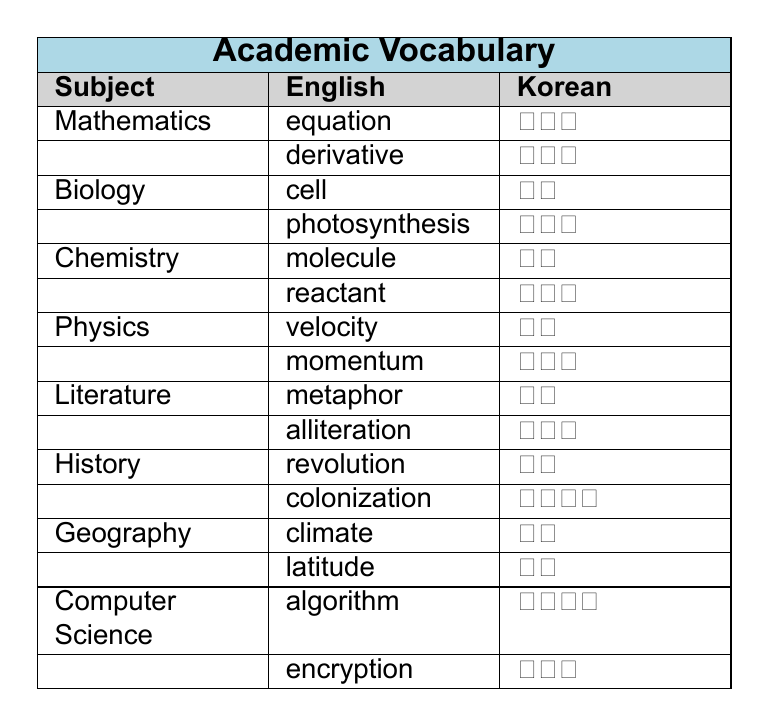What is the Korean word for 'algorithm'? From the vocabulary list, under the subject 'Computer Science', the English word 'algorithm' corresponds to the Korean word '알고리즘'.
Answer: 알고리즘 Which subject has the term 'momentum'? Referring to the table, 'momentum' is listed under the subject 'Physics'.
Answer: Physics How many vocabulary terms are listed for the subject 'Biology'? The vocabulary for 'Biology' includes two terms: 'cell' and 'photosynthesis'. Therefore, the count is 2.
Answer: 2 What English word corresponds to '혁명'? Looking at the table, '혁명' is the Korean word that translates to 'revolution' in English, found under the subject 'History'.
Answer: revolution Is 'molecule' included in the vocabulary list for Mathematics? Checking the table, 'molecule' is not under Mathematics; it is listed under Chemistry. Therefore, the answer is no.
Answer: No Which subject has the term 'latitude'? In the table, 'latitude' is identified under the subject 'Geography'.
Answer: Geography What are the English words for the subjects of 'Chemistry' and 'Literature'? 'Chemistry' has 'molecule' and 'reactant'; 'Literature' has 'metaphor' and 'alliteration'. Thus, the total words are four: molecule, reactant, metaphor, alliteration.
Answer: molecule, reactant, metaphor, alliteration Count the total number of vocabulary terms in the table. There are 16 vocabulary terms total, as each subject has 2 terms listed. Summing them gives 8 subjects x 2 terms each = 16.
Answer: 16 Does the subject 'Geography' include the word 'climate'? The table displays 'climate' under the subject 'Geography', confirming its inclusion. Therefore, the answer is yes.
Answer: Yes Which academic subject has the most vocabulary entries? All subjects have the same number of entries (2 each), so no subject has more vocabulary entries than the others.
Answer: None (all are equal) 